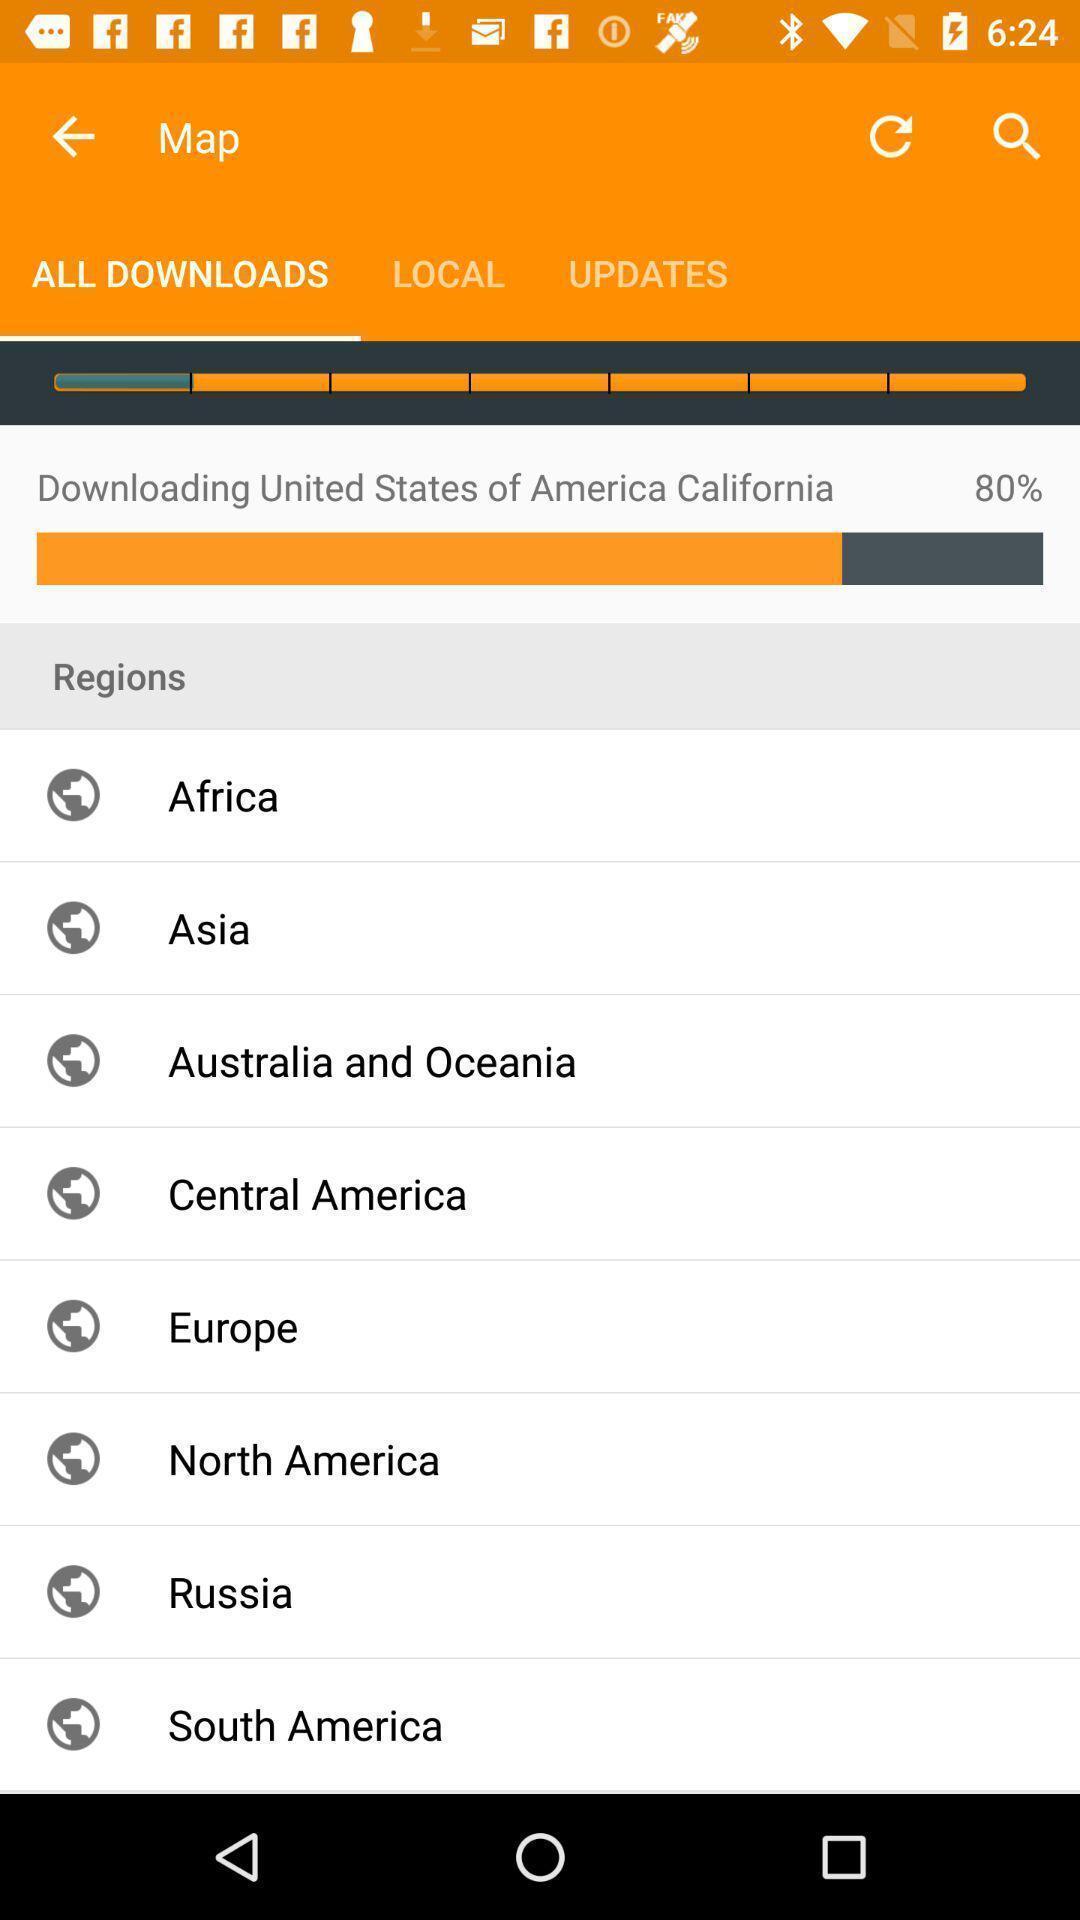Summarize the information in this screenshot. Page showing different regions on an app. 